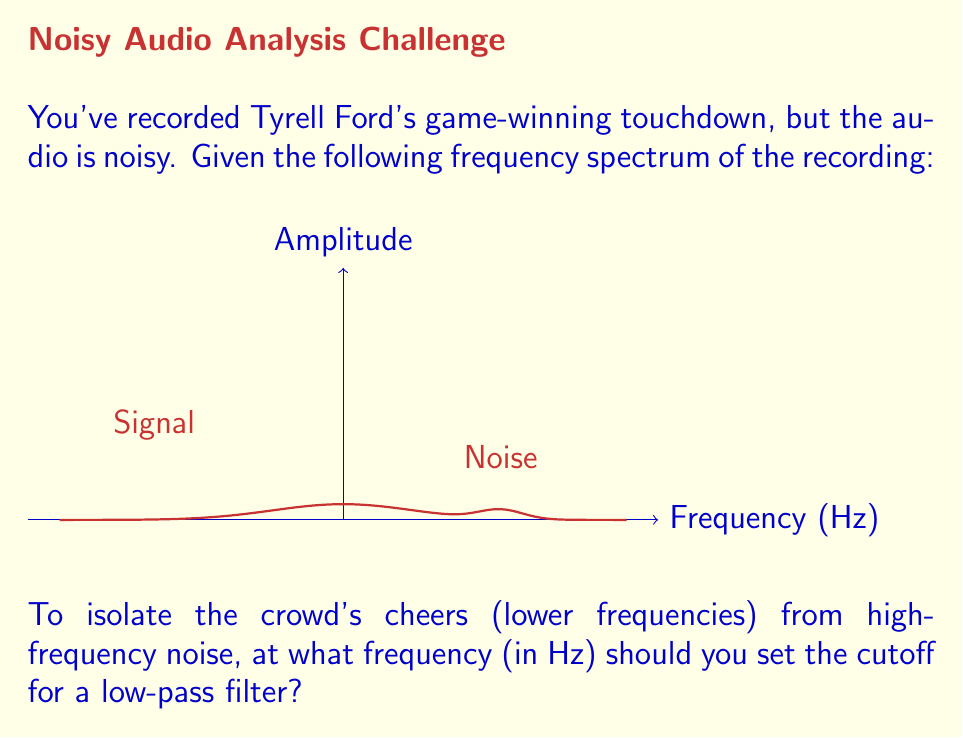Teach me how to tackle this problem. Let's approach this step-by-step:

1) The Fourier transform converts the audio signal from the time domain to the frequency domain, allowing us to analyze its frequency components.

2) In the given spectrum, we can see two main components:
   - A broader peak centered around 0 Hz (the signal)
   - A narrower peak centered around 50 Hz (the noise)

3) The signal (crowd cheers) is concentrated in the lower frequencies, while the noise is at higher frequencies.

4) To design a low-pass filter, we need to choose a cutoff frequency $f_c$ that preserves the signal while attenuating the noise.

5) The ideal cutoff would be between the signal and noise peaks. From the graph, we can estimate this point to be approximately halfway between 0 and 50 Hz.

6) Therefore, a suitable cutoff frequency would be:

   $$f_c = \frac{0 + 50}{2} = 25 \text{ Hz}$$

7) The low-pass filter will then be defined as:

   $$H(f) = \begin{cases} 
   1, & \text{if } |f| \leq 25 \text{ Hz} \\
   0, & \text{if } |f| > 25 \text{ Hz}
   \end{cases}$$

8) Applying this filter in the frequency domain and then performing an inverse Fourier transform will give us the cleaned audio signal, emphasizing Tyrell Ford's game-winning moment.
Answer: 25 Hz 